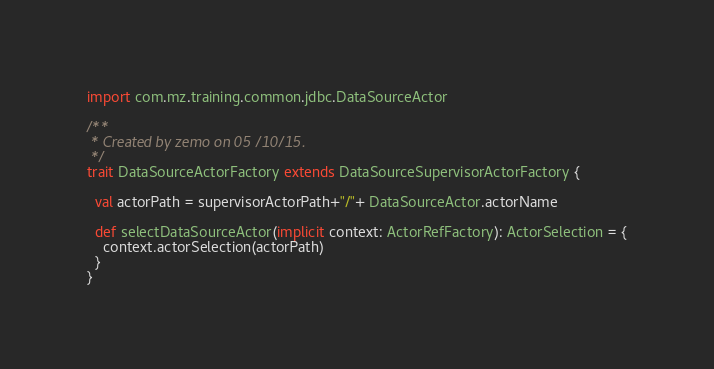Convert code to text. <code><loc_0><loc_0><loc_500><loc_500><_Scala_>import com.mz.training.common.jdbc.DataSourceActor

/**
 * Created by zemo on 05/10/15.
 */
trait DataSourceActorFactory extends DataSourceSupervisorActorFactory {

  val actorPath = supervisorActorPath+"/"+ DataSourceActor.actorName

  def selectDataSourceActor(implicit context: ActorRefFactory): ActorSelection = {
    context.actorSelection(actorPath)
  }
}
</code> 